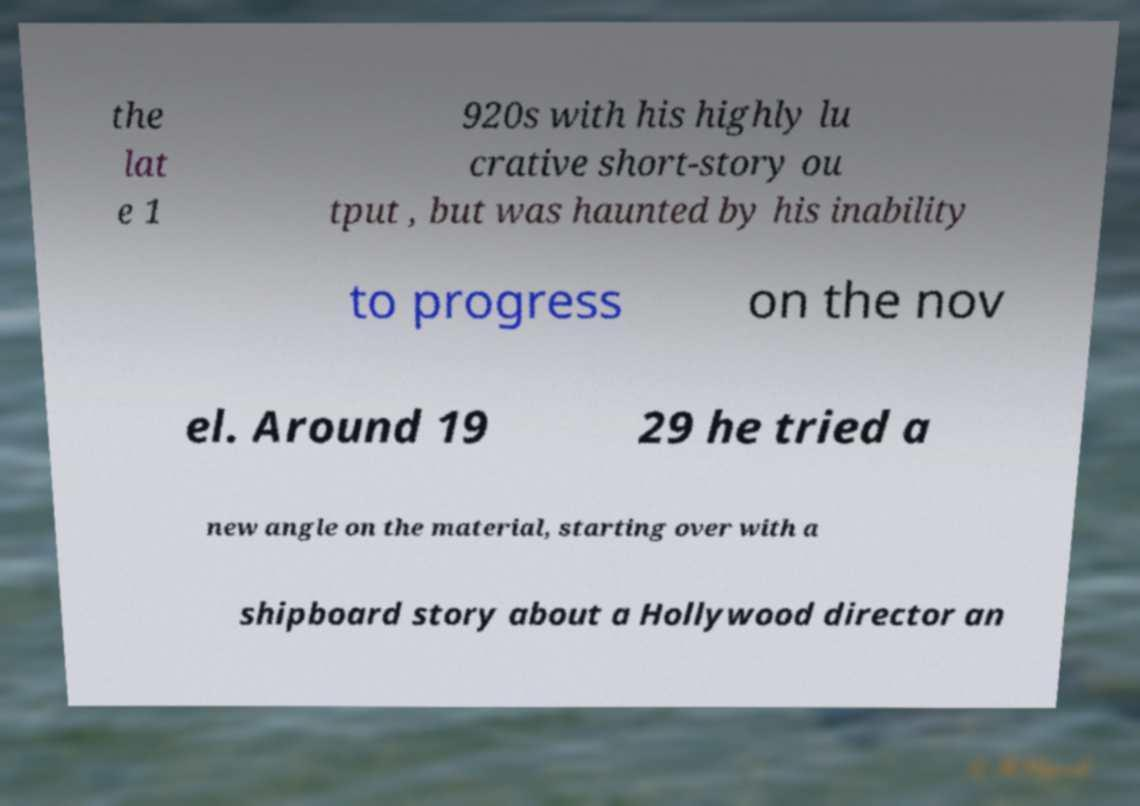Please identify and transcribe the text found in this image. the lat e 1 920s with his highly lu crative short-story ou tput , but was haunted by his inability to progress on the nov el. Around 19 29 he tried a new angle on the material, starting over with a shipboard story about a Hollywood director an 